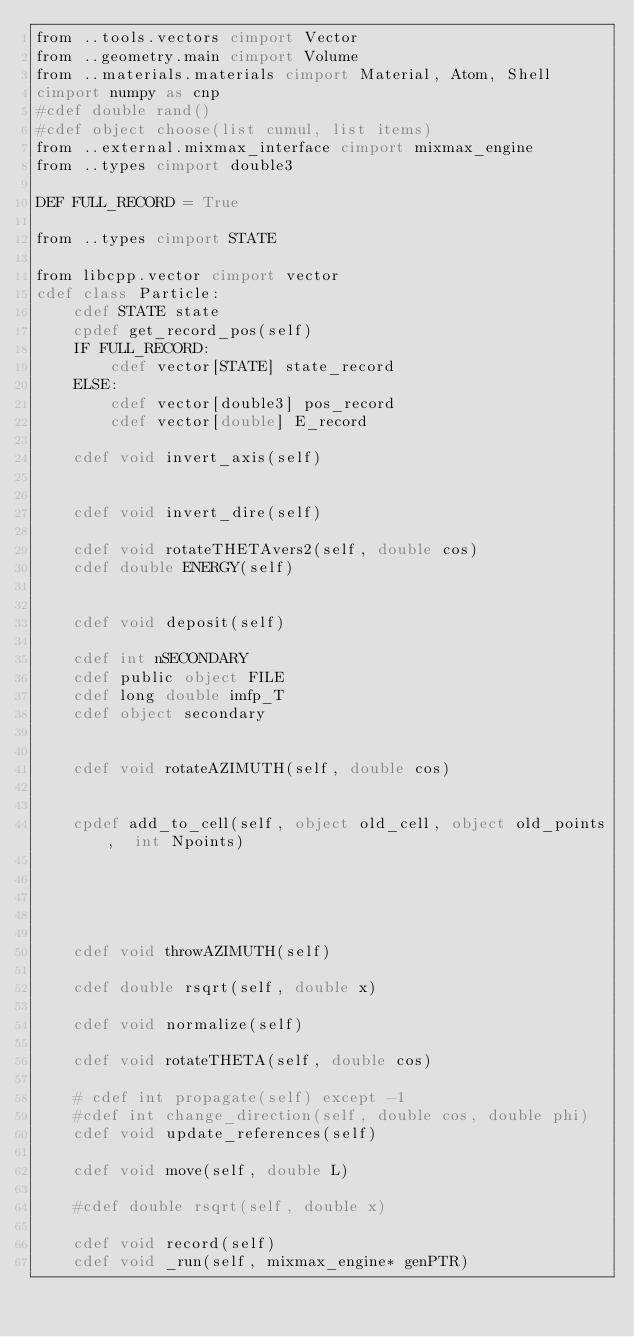<code> <loc_0><loc_0><loc_500><loc_500><_Cython_>from ..tools.vectors cimport Vector
from ..geometry.main cimport Volume
from ..materials.materials cimport Material, Atom, Shell
cimport numpy as cnp
#cdef double rand()
#cdef object choose(list cumul, list items)
from ..external.mixmax_interface cimport mixmax_engine
from ..types cimport double3

DEF FULL_RECORD = True

from ..types cimport STATE

from libcpp.vector cimport vector
cdef class Particle:
    cdef STATE state
    cpdef get_record_pos(self)
    IF FULL_RECORD:
        cdef vector[STATE] state_record
    ELSE:
        cdef vector[double3] pos_record
        cdef vector[double] E_record

    cdef void invert_axis(self)


    cdef void invert_dire(self)

    cdef void rotateTHETAvers2(self, double cos)
    cdef double ENERGY(self)


    cdef void deposit(self)

    cdef int nSECONDARY
    cdef public object FILE
    cdef long double imfp_T
    cdef object secondary
    

    cdef void rotateAZIMUTH(self, double cos)
    
    
    cpdef add_to_cell(self, object old_cell, object old_points,  int Npoints)

    

    
    
    cdef void throwAZIMUTH(self)
    
    cdef double rsqrt(self, double x)
    
    cdef void normalize(self)
    
    cdef void rotateTHETA(self, double cos)
    
    # cdef int propagate(self) except -1
    #cdef int change_direction(self, double cos, double phi)
    cdef void update_references(self)
    
    cdef void move(self, double L)

    #cdef double rsqrt(self, double x)

    cdef void record(self)
    cdef void _run(self, mixmax_engine* genPTR)</code> 